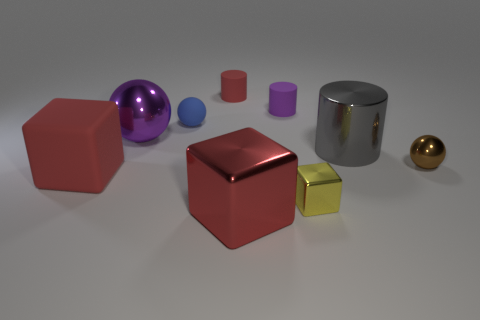The small sphere left of the sphere right of the red cylinder is made of what material?
Offer a terse response. Rubber. How many things are brown matte objects or big red rubber things to the left of the big purple ball?
Give a very brief answer. 1. What size is the red block that is the same material as the blue thing?
Keep it short and to the point. Large. Is the number of purple things that are on the right side of the gray thing greater than the number of tiny metal cubes?
Your answer should be very brief. No. How big is the shiny thing that is in front of the purple ball and on the left side of the tiny yellow thing?
Offer a terse response. Large. There is another small object that is the same shape as the tiny brown metallic object; what is it made of?
Keep it short and to the point. Rubber. Does the rubber cylinder to the left of the purple cylinder have the same size as the small brown shiny thing?
Offer a very short reply. Yes. What is the color of the tiny object that is to the right of the tiny red cylinder and behind the purple ball?
Offer a terse response. Purple. What number of spheres are in front of the purple object that is in front of the tiny purple rubber object?
Offer a very short reply. 1. Is the shape of the small brown metal object the same as the red metallic thing?
Keep it short and to the point. No. 